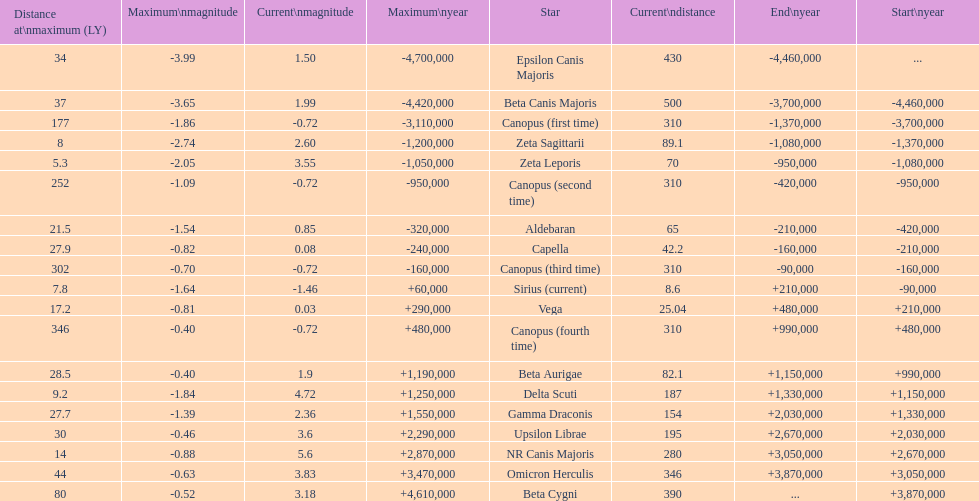Which star has the greatest maximum distance? Canopus (fourth time). 